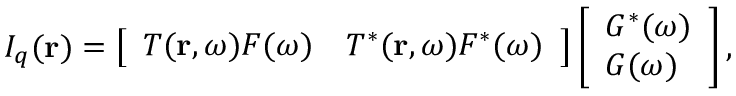Convert formula to latex. <formula><loc_0><loc_0><loc_500><loc_500>I _ { q } ( r ) = \left [ \begin{array} { l l } { T ( r , \omega ) F ( \omega ) } & { T ^ { * } ( r , \omega ) F ^ { * } ( \omega ) } \end{array} \right ] \left [ \begin{array} { l } { G ^ { * } ( \omega ) } \\ { G ( \omega ) } \end{array} \right ] ,</formula> 